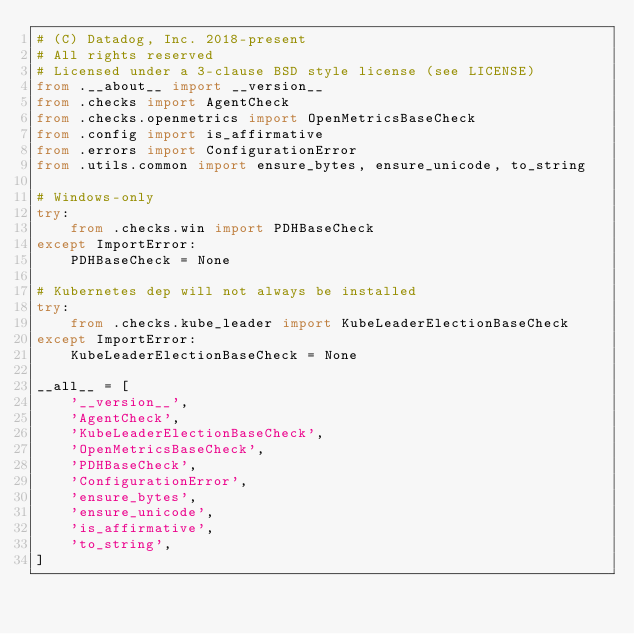<code> <loc_0><loc_0><loc_500><loc_500><_Python_># (C) Datadog, Inc. 2018-present
# All rights reserved
# Licensed under a 3-clause BSD style license (see LICENSE)
from .__about__ import __version__
from .checks import AgentCheck
from .checks.openmetrics import OpenMetricsBaseCheck
from .config import is_affirmative
from .errors import ConfigurationError
from .utils.common import ensure_bytes, ensure_unicode, to_string

# Windows-only
try:
    from .checks.win import PDHBaseCheck
except ImportError:
    PDHBaseCheck = None

# Kubernetes dep will not always be installed
try:
    from .checks.kube_leader import KubeLeaderElectionBaseCheck
except ImportError:
    KubeLeaderElectionBaseCheck = None

__all__ = [
    '__version__',
    'AgentCheck',
    'KubeLeaderElectionBaseCheck',
    'OpenMetricsBaseCheck',
    'PDHBaseCheck',
    'ConfigurationError',
    'ensure_bytes',
    'ensure_unicode',
    'is_affirmative',
    'to_string',
]
</code> 